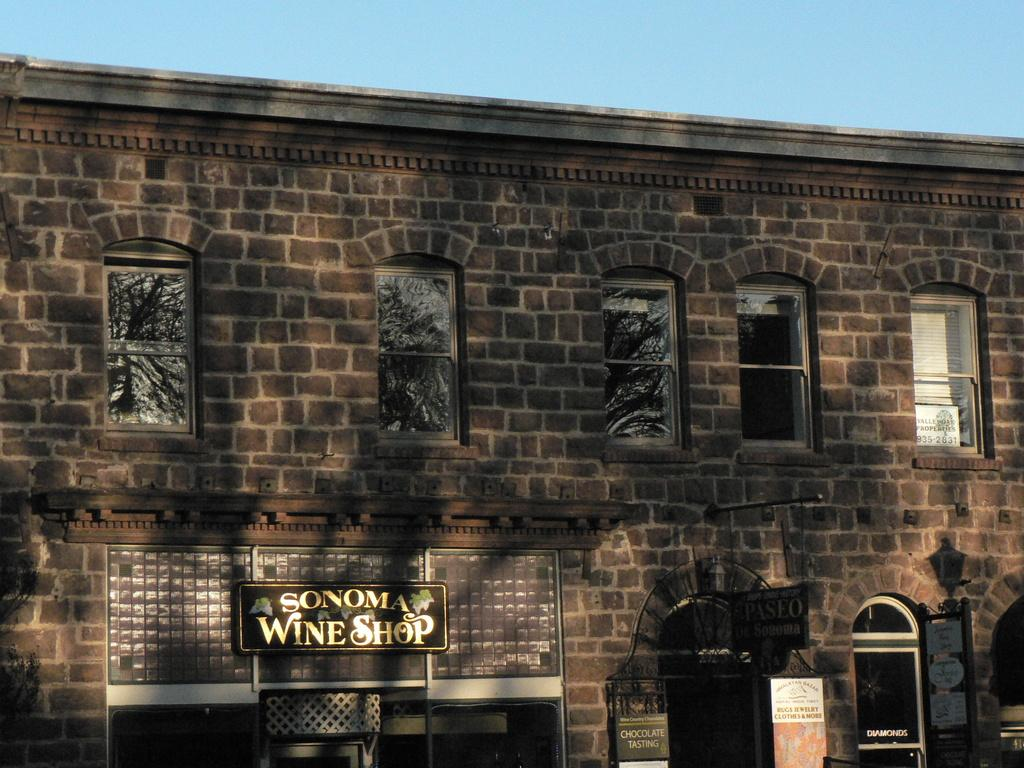<image>
Create a compact narrative representing the image presented. older brick building with a sign identifying it as sonoma wine shop 